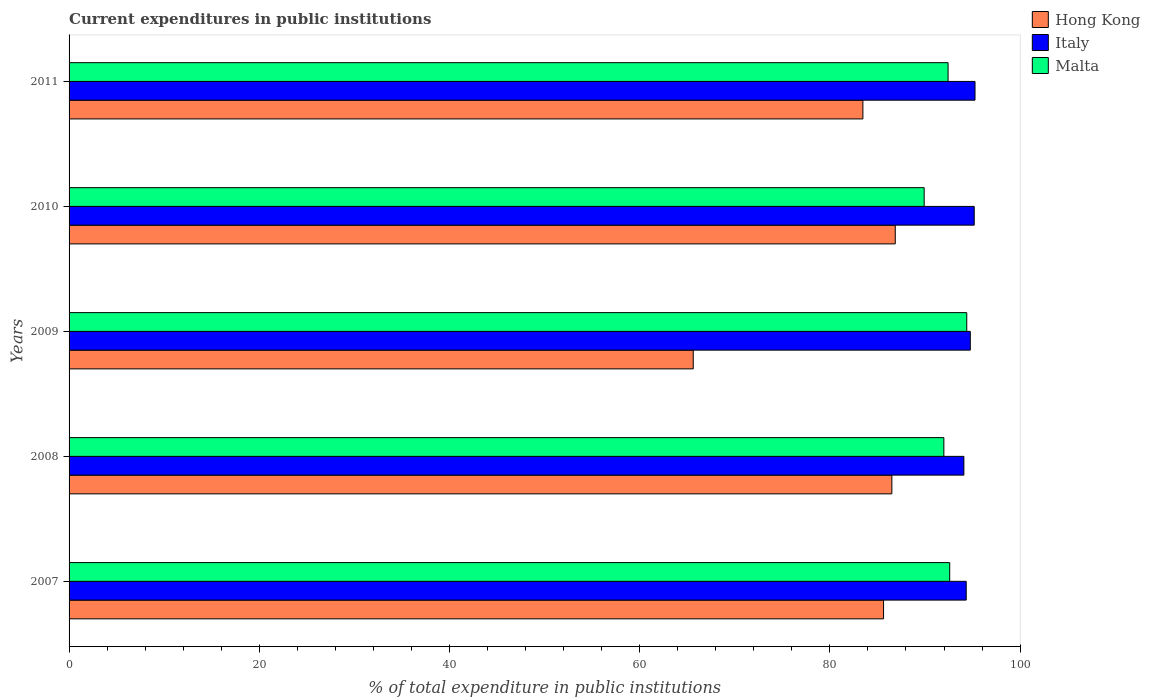How many different coloured bars are there?
Offer a very short reply. 3. Are the number of bars per tick equal to the number of legend labels?
Offer a terse response. Yes. How many bars are there on the 2nd tick from the bottom?
Your response must be concise. 3. What is the label of the 4th group of bars from the top?
Your response must be concise. 2008. What is the current expenditures in public institutions in Hong Kong in 2008?
Make the answer very short. 86.52. Across all years, what is the maximum current expenditures in public institutions in Italy?
Give a very brief answer. 95.26. Across all years, what is the minimum current expenditures in public institutions in Malta?
Provide a succinct answer. 89.92. In which year was the current expenditures in public institutions in Hong Kong minimum?
Your response must be concise. 2009. What is the total current expenditures in public institutions in Hong Kong in the graph?
Give a very brief answer. 408.14. What is the difference between the current expenditures in public institutions in Malta in 2009 and that in 2010?
Your answer should be compact. 4.48. What is the difference between the current expenditures in public institutions in Hong Kong in 2009 and the current expenditures in public institutions in Italy in 2007?
Offer a very short reply. -28.7. What is the average current expenditures in public institutions in Hong Kong per year?
Keep it short and to the point. 81.63. In the year 2007, what is the difference between the current expenditures in public institutions in Italy and current expenditures in public institutions in Hong Kong?
Your answer should be compact. 8.69. What is the ratio of the current expenditures in public institutions in Hong Kong in 2009 to that in 2010?
Your answer should be very brief. 0.76. Is the difference between the current expenditures in public institutions in Italy in 2007 and 2008 greater than the difference between the current expenditures in public institutions in Hong Kong in 2007 and 2008?
Offer a terse response. Yes. What is the difference between the highest and the second highest current expenditures in public institutions in Hong Kong?
Your response must be concise. 0.36. What is the difference between the highest and the lowest current expenditures in public institutions in Italy?
Offer a terse response. 1.17. In how many years, is the current expenditures in public institutions in Italy greater than the average current expenditures in public institutions in Italy taken over all years?
Provide a short and direct response. 3. What does the 1st bar from the top in 2007 represents?
Your answer should be compact. Malta. What does the 3rd bar from the bottom in 2010 represents?
Provide a succinct answer. Malta. Is it the case that in every year, the sum of the current expenditures in public institutions in Italy and current expenditures in public institutions in Hong Kong is greater than the current expenditures in public institutions in Malta?
Your response must be concise. Yes. How many bars are there?
Your answer should be compact. 15. What is the difference between two consecutive major ticks on the X-axis?
Provide a short and direct response. 20. Are the values on the major ticks of X-axis written in scientific E-notation?
Ensure brevity in your answer.  No. Does the graph contain any zero values?
Your answer should be compact. No. Does the graph contain grids?
Your answer should be very brief. No. What is the title of the graph?
Your answer should be compact. Current expenditures in public institutions. What is the label or title of the X-axis?
Offer a very short reply. % of total expenditure in public institutions. What is the % of total expenditure in public institutions in Hong Kong in 2007?
Your answer should be compact. 85.65. What is the % of total expenditure in public institutions in Italy in 2007?
Your answer should be compact. 94.34. What is the % of total expenditure in public institutions of Malta in 2007?
Your answer should be compact. 92.6. What is the % of total expenditure in public institutions of Hong Kong in 2008?
Make the answer very short. 86.52. What is the % of total expenditure in public institutions of Italy in 2008?
Your response must be concise. 94.09. What is the % of total expenditure in public institutions in Malta in 2008?
Offer a terse response. 91.99. What is the % of total expenditure in public institutions of Hong Kong in 2009?
Provide a succinct answer. 65.63. What is the % of total expenditure in public institutions of Italy in 2009?
Your response must be concise. 94.76. What is the % of total expenditure in public institutions in Malta in 2009?
Your answer should be very brief. 94.39. What is the % of total expenditure in public institutions of Hong Kong in 2010?
Provide a succinct answer. 86.88. What is the % of total expenditure in public institutions in Italy in 2010?
Make the answer very short. 95.18. What is the % of total expenditure in public institutions in Malta in 2010?
Provide a succinct answer. 89.92. What is the % of total expenditure in public institutions of Hong Kong in 2011?
Give a very brief answer. 83.47. What is the % of total expenditure in public institutions in Italy in 2011?
Provide a short and direct response. 95.26. What is the % of total expenditure in public institutions in Malta in 2011?
Your answer should be compact. 92.43. Across all years, what is the maximum % of total expenditure in public institutions in Hong Kong?
Give a very brief answer. 86.88. Across all years, what is the maximum % of total expenditure in public institutions of Italy?
Your answer should be very brief. 95.26. Across all years, what is the maximum % of total expenditure in public institutions in Malta?
Ensure brevity in your answer.  94.39. Across all years, what is the minimum % of total expenditure in public institutions in Hong Kong?
Offer a very short reply. 65.63. Across all years, what is the minimum % of total expenditure in public institutions of Italy?
Provide a succinct answer. 94.09. Across all years, what is the minimum % of total expenditure in public institutions in Malta?
Give a very brief answer. 89.92. What is the total % of total expenditure in public institutions of Hong Kong in the graph?
Offer a terse response. 408.14. What is the total % of total expenditure in public institutions of Italy in the graph?
Provide a succinct answer. 473.63. What is the total % of total expenditure in public institutions of Malta in the graph?
Offer a very short reply. 461.32. What is the difference between the % of total expenditure in public institutions in Hong Kong in 2007 and that in 2008?
Give a very brief answer. -0.87. What is the difference between the % of total expenditure in public institutions in Italy in 2007 and that in 2008?
Provide a short and direct response. 0.25. What is the difference between the % of total expenditure in public institutions of Malta in 2007 and that in 2008?
Offer a very short reply. 0.61. What is the difference between the % of total expenditure in public institutions of Hong Kong in 2007 and that in 2009?
Give a very brief answer. 20.01. What is the difference between the % of total expenditure in public institutions in Italy in 2007 and that in 2009?
Provide a succinct answer. -0.43. What is the difference between the % of total expenditure in public institutions in Malta in 2007 and that in 2009?
Your answer should be compact. -1.79. What is the difference between the % of total expenditure in public institutions in Hong Kong in 2007 and that in 2010?
Offer a terse response. -1.23. What is the difference between the % of total expenditure in public institutions in Italy in 2007 and that in 2010?
Provide a short and direct response. -0.84. What is the difference between the % of total expenditure in public institutions of Malta in 2007 and that in 2010?
Your answer should be compact. 2.68. What is the difference between the % of total expenditure in public institutions of Hong Kong in 2007 and that in 2011?
Offer a very short reply. 2.17. What is the difference between the % of total expenditure in public institutions in Italy in 2007 and that in 2011?
Your answer should be compact. -0.92. What is the difference between the % of total expenditure in public institutions in Malta in 2007 and that in 2011?
Your answer should be very brief. 0.17. What is the difference between the % of total expenditure in public institutions in Hong Kong in 2008 and that in 2009?
Ensure brevity in your answer.  20.89. What is the difference between the % of total expenditure in public institutions in Italy in 2008 and that in 2009?
Offer a terse response. -0.67. What is the difference between the % of total expenditure in public institutions of Malta in 2008 and that in 2009?
Ensure brevity in your answer.  -2.41. What is the difference between the % of total expenditure in public institutions in Hong Kong in 2008 and that in 2010?
Offer a very short reply. -0.36. What is the difference between the % of total expenditure in public institutions in Italy in 2008 and that in 2010?
Your response must be concise. -1.09. What is the difference between the % of total expenditure in public institutions of Malta in 2008 and that in 2010?
Make the answer very short. 2.07. What is the difference between the % of total expenditure in public institutions of Hong Kong in 2008 and that in 2011?
Keep it short and to the point. 3.05. What is the difference between the % of total expenditure in public institutions of Italy in 2008 and that in 2011?
Offer a terse response. -1.17. What is the difference between the % of total expenditure in public institutions in Malta in 2008 and that in 2011?
Your answer should be compact. -0.44. What is the difference between the % of total expenditure in public institutions of Hong Kong in 2009 and that in 2010?
Provide a short and direct response. -21.24. What is the difference between the % of total expenditure in public institutions in Italy in 2009 and that in 2010?
Keep it short and to the point. -0.41. What is the difference between the % of total expenditure in public institutions in Malta in 2009 and that in 2010?
Your answer should be very brief. 4.48. What is the difference between the % of total expenditure in public institutions in Hong Kong in 2009 and that in 2011?
Your response must be concise. -17.84. What is the difference between the % of total expenditure in public institutions of Italy in 2009 and that in 2011?
Offer a very short reply. -0.5. What is the difference between the % of total expenditure in public institutions of Malta in 2009 and that in 2011?
Make the answer very short. 1.96. What is the difference between the % of total expenditure in public institutions of Hong Kong in 2010 and that in 2011?
Your response must be concise. 3.4. What is the difference between the % of total expenditure in public institutions in Italy in 2010 and that in 2011?
Offer a very short reply. -0.08. What is the difference between the % of total expenditure in public institutions in Malta in 2010 and that in 2011?
Provide a succinct answer. -2.51. What is the difference between the % of total expenditure in public institutions of Hong Kong in 2007 and the % of total expenditure in public institutions of Italy in 2008?
Make the answer very short. -8.44. What is the difference between the % of total expenditure in public institutions in Hong Kong in 2007 and the % of total expenditure in public institutions in Malta in 2008?
Give a very brief answer. -6.34. What is the difference between the % of total expenditure in public institutions of Italy in 2007 and the % of total expenditure in public institutions of Malta in 2008?
Keep it short and to the point. 2.35. What is the difference between the % of total expenditure in public institutions of Hong Kong in 2007 and the % of total expenditure in public institutions of Italy in 2009?
Your response must be concise. -9.12. What is the difference between the % of total expenditure in public institutions of Hong Kong in 2007 and the % of total expenditure in public institutions of Malta in 2009?
Keep it short and to the point. -8.75. What is the difference between the % of total expenditure in public institutions in Italy in 2007 and the % of total expenditure in public institutions in Malta in 2009?
Provide a short and direct response. -0.05. What is the difference between the % of total expenditure in public institutions in Hong Kong in 2007 and the % of total expenditure in public institutions in Italy in 2010?
Ensure brevity in your answer.  -9.53. What is the difference between the % of total expenditure in public institutions of Hong Kong in 2007 and the % of total expenditure in public institutions of Malta in 2010?
Your response must be concise. -4.27. What is the difference between the % of total expenditure in public institutions of Italy in 2007 and the % of total expenditure in public institutions of Malta in 2010?
Make the answer very short. 4.42. What is the difference between the % of total expenditure in public institutions of Hong Kong in 2007 and the % of total expenditure in public institutions of Italy in 2011?
Provide a succinct answer. -9.62. What is the difference between the % of total expenditure in public institutions in Hong Kong in 2007 and the % of total expenditure in public institutions in Malta in 2011?
Your answer should be compact. -6.78. What is the difference between the % of total expenditure in public institutions of Italy in 2007 and the % of total expenditure in public institutions of Malta in 2011?
Make the answer very short. 1.91. What is the difference between the % of total expenditure in public institutions of Hong Kong in 2008 and the % of total expenditure in public institutions of Italy in 2009?
Provide a succinct answer. -8.25. What is the difference between the % of total expenditure in public institutions in Hong Kong in 2008 and the % of total expenditure in public institutions in Malta in 2009?
Your response must be concise. -7.87. What is the difference between the % of total expenditure in public institutions of Italy in 2008 and the % of total expenditure in public institutions of Malta in 2009?
Keep it short and to the point. -0.3. What is the difference between the % of total expenditure in public institutions in Hong Kong in 2008 and the % of total expenditure in public institutions in Italy in 2010?
Keep it short and to the point. -8.66. What is the difference between the % of total expenditure in public institutions of Hong Kong in 2008 and the % of total expenditure in public institutions of Malta in 2010?
Give a very brief answer. -3.4. What is the difference between the % of total expenditure in public institutions of Italy in 2008 and the % of total expenditure in public institutions of Malta in 2010?
Provide a short and direct response. 4.17. What is the difference between the % of total expenditure in public institutions of Hong Kong in 2008 and the % of total expenditure in public institutions of Italy in 2011?
Provide a succinct answer. -8.74. What is the difference between the % of total expenditure in public institutions of Hong Kong in 2008 and the % of total expenditure in public institutions of Malta in 2011?
Ensure brevity in your answer.  -5.91. What is the difference between the % of total expenditure in public institutions in Italy in 2008 and the % of total expenditure in public institutions in Malta in 2011?
Your answer should be very brief. 1.66. What is the difference between the % of total expenditure in public institutions of Hong Kong in 2009 and the % of total expenditure in public institutions of Italy in 2010?
Offer a terse response. -29.55. What is the difference between the % of total expenditure in public institutions of Hong Kong in 2009 and the % of total expenditure in public institutions of Malta in 2010?
Give a very brief answer. -24.28. What is the difference between the % of total expenditure in public institutions in Italy in 2009 and the % of total expenditure in public institutions in Malta in 2010?
Your answer should be compact. 4.85. What is the difference between the % of total expenditure in public institutions of Hong Kong in 2009 and the % of total expenditure in public institutions of Italy in 2011?
Provide a succinct answer. -29.63. What is the difference between the % of total expenditure in public institutions of Hong Kong in 2009 and the % of total expenditure in public institutions of Malta in 2011?
Your answer should be very brief. -26.8. What is the difference between the % of total expenditure in public institutions of Italy in 2009 and the % of total expenditure in public institutions of Malta in 2011?
Offer a very short reply. 2.34. What is the difference between the % of total expenditure in public institutions in Hong Kong in 2010 and the % of total expenditure in public institutions in Italy in 2011?
Offer a very short reply. -8.38. What is the difference between the % of total expenditure in public institutions in Hong Kong in 2010 and the % of total expenditure in public institutions in Malta in 2011?
Your answer should be compact. -5.55. What is the difference between the % of total expenditure in public institutions in Italy in 2010 and the % of total expenditure in public institutions in Malta in 2011?
Your answer should be very brief. 2.75. What is the average % of total expenditure in public institutions of Hong Kong per year?
Keep it short and to the point. 81.63. What is the average % of total expenditure in public institutions in Italy per year?
Give a very brief answer. 94.73. What is the average % of total expenditure in public institutions in Malta per year?
Offer a very short reply. 92.26. In the year 2007, what is the difference between the % of total expenditure in public institutions in Hong Kong and % of total expenditure in public institutions in Italy?
Offer a terse response. -8.69. In the year 2007, what is the difference between the % of total expenditure in public institutions of Hong Kong and % of total expenditure in public institutions of Malta?
Your response must be concise. -6.95. In the year 2007, what is the difference between the % of total expenditure in public institutions of Italy and % of total expenditure in public institutions of Malta?
Provide a short and direct response. 1.74. In the year 2008, what is the difference between the % of total expenditure in public institutions in Hong Kong and % of total expenditure in public institutions in Italy?
Offer a very short reply. -7.57. In the year 2008, what is the difference between the % of total expenditure in public institutions in Hong Kong and % of total expenditure in public institutions in Malta?
Your response must be concise. -5.47. In the year 2008, what is the difference between the % of total expenditure in public institutions in Italy and % of total expenditure in public institutions in Malta?
Offer a very short reply. 2.1. In the year 2009, what is the difference between the % of total expenditure in public institutions of Hong Kong and % of total expenditure in public institutions of Italy?
Give a very brief answer. -29.13. In the year 2009, what is the difference between the % of total expenditure in public institutions in Hong Kong and % of total expenditure in public institutions in Malta?
Keep it short and to the point. -28.76. In the year 2009, what is the difference between the % of total expenditure in public institutions in Italy and % of total expenditure in public institutions in Malta?
Give a very brief answer. 0.37. In the year 2010, what is the difference between the % of total expenditure in public institutions in Hong Kong and % of total expenditure in public institutions in Italy?
Your answer should be compact. -8.3. In the year 2010, what is the difference between the % of total expenditure in public institutions of Hong Kong and % of total expenditure in public institutions of Malta?
Give a very brief answer. -3.04. In the year 2010, what is the difference between the % of total expenditure in public institutions in Italy and % of total expenditure in public institutions in Malta?
Ensure brevity in your answer.  5.26. In the year 2011, what is the difference between the % of total expenditure in public institutions in Hong Kong and % of total expenditure in public institutions in Italy?
Offer a very short reply. -11.79. In the year 2011, what is the difference between the % of total expenditure in public institutions in Hong Kong and % of total expenditure in public institutions in Malta?
Your answer should be compact. -8.96. In the year 2011, what is the difference between the % of total expenditure in public institutions in Italy and % of total expenditure in public institutions in Malta?
Your response must be concise. 2.83. What is the ratio of the % of total expenditure in public institutions of Hong Kong in 2007 to that in 2008?
Your answer should be compact. 0.99. What is the ratio of the % of total expenditure in public institutions in Italy in 2007 to that in 2008?
Give a very brief answer. 1. What is the ratio of the % of total expenditure in public institutions of Malta in 2007 to that in 2008?
Ensure brevity in your answer.  1.01. What is the ratio of the % of total expenditure in public institutions in Hong Kong in 2007 to that in 2009?
Ensure brevity in your answer.  1.3. What is the ratio of the % of total expenditure in public institutions in Italy in 2007 to that in 2009?
Your answer should be very brief. 1. What is the ratio of the % of total expenditure in public institutions in Hong Kong in 2007 to that in 2010?
Your answer should be very brief. 0.99. What is the ratio of the % of total expenditure in public institutions of Italy in 2007 to that in 2010?
Your answer should be very brief. 0.99. What is the ratio of the % of total expenditure in public institutions of Malta in 2007 to that in 2010?
Provide a short and direct response. 1.03. What is the ratio of the % of total expenditure in public institutions in Italy in 2007 to that in 2011?
Make the answer very short. 0.99. What is the ratio of the % of total expenditure in public institutions in Malta in 2007 to that in 2011?
Provide a succinct answer. 1. What is the ratio of the % of total expenditure in public institutions of Hong Kong in 2008 to that in 2009?
Make the answer very short. 1.32. What is the ratio of the % of total expenditure in public institutions of Malta in 2008 to that in 2009?
Provide a short and direct response. 0.97. What is the ratio of the % of total expenditure in public institutions in Hong Kong in 2008 to that in 2010?
Offer a terse response. 1. What is the ratio of the % of total expenditure in public institutions in Malta in 2008 to that in 2010?
Your response must be concise. 1.02. What is the ratio of the % of total expenditure in public institutions in Hong Kong in 2008 to that in 2011?
Ensure brevity in your answer.  1.04. What is the ratio of the % of total expenditure in public institutions of Italy in 2008 to that in 2011?
Give a very brief answer. 0.99. What is the ratio of the % of total expenditure in public institutions of Malta in 2008 to that in 2011?
Offer a terse response. 1. What is the ratio of the % of total expenditure in public institutions in Hong Kong in 2009 to that in 2010?
Provide a succinct answer. 0.76. What is the ratio of the % of total expenditure in public institutions of Italy in 2009 to that in 2010?
Offer a terse response. 1. What is the ratio of the % of total expenditure in public institutions of Malta in 2009 to that in 2010?
Your response must be concise. 1.05. What is the ratio of the % of total expenditure in public institutions in Hong Kong in 2009 to that in 2011?
Provide a short and direct response. 0.79. What is the ratio of the % of total expenditure in public institutions in Italy in 2009 to that in 2011?
Provide a short and direct response. 0.99. What is the ratio of the % of total expenditure in public institutions in Malta in 2009 to that in 2011?
Offer a terse response. 1.02. What is the ratio of the % of total expenditure in public institutions in Hong Kong in 2010 to that in 2011?
Keep it short and to the point. 1.04. What is the ratio of the % of total expenditure in public institutions in Italy in 2010 to that in 2011?
Your answer should be very brief. 1. What is the ratio of the % of total expenditure in public institutions of Malta in 2010 to that in 2011?
Give a very brief answer. 0.97. What is the difference between the highest and the second highest % of total expenditure in public institutions of Hong Kong?
Provide a short and direct response. 0.36. What is the difference between the highest and the second highest % of total expenditure in public institutions of Italy?
Your response must be concise. 0.08. What is the difference between the highest and the second highest % of total expenditure in public institutions in Malta?
Offer a very short reply. 1.79. What is the difference between the highest and the lowest % of total expenditure in public institutions of Hong Kong?
Offer a very short reply. 21.24. What is the difference between the highest and the lowest % of total expenditure in public institutions in Italy?
Provide a short and direct response. 1.17. What is the difference between the highest and the lowest % of total expenditure in public institutions of Malta?
Provide a succinct answer. 4.48. 